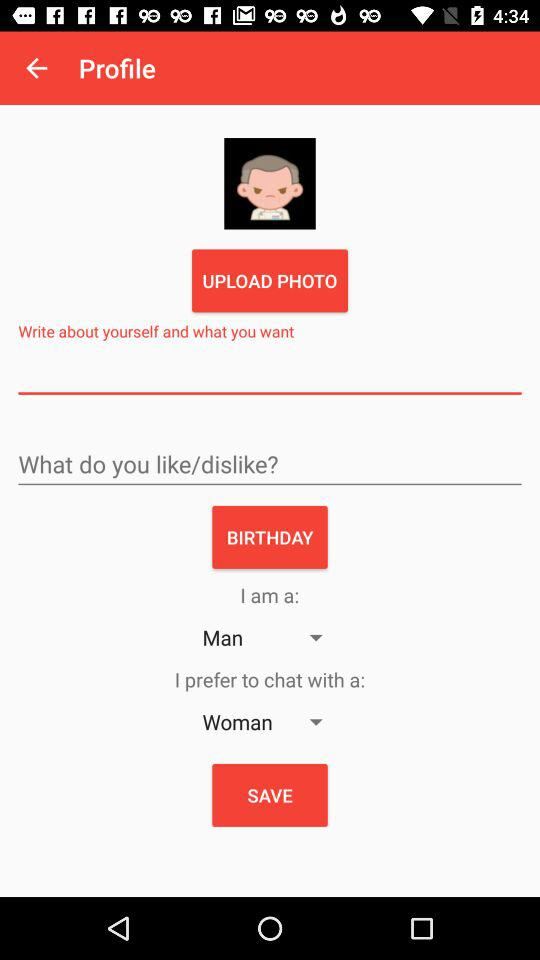What gender does the user prefer to chat with? The user prefers to chat with a woman. 